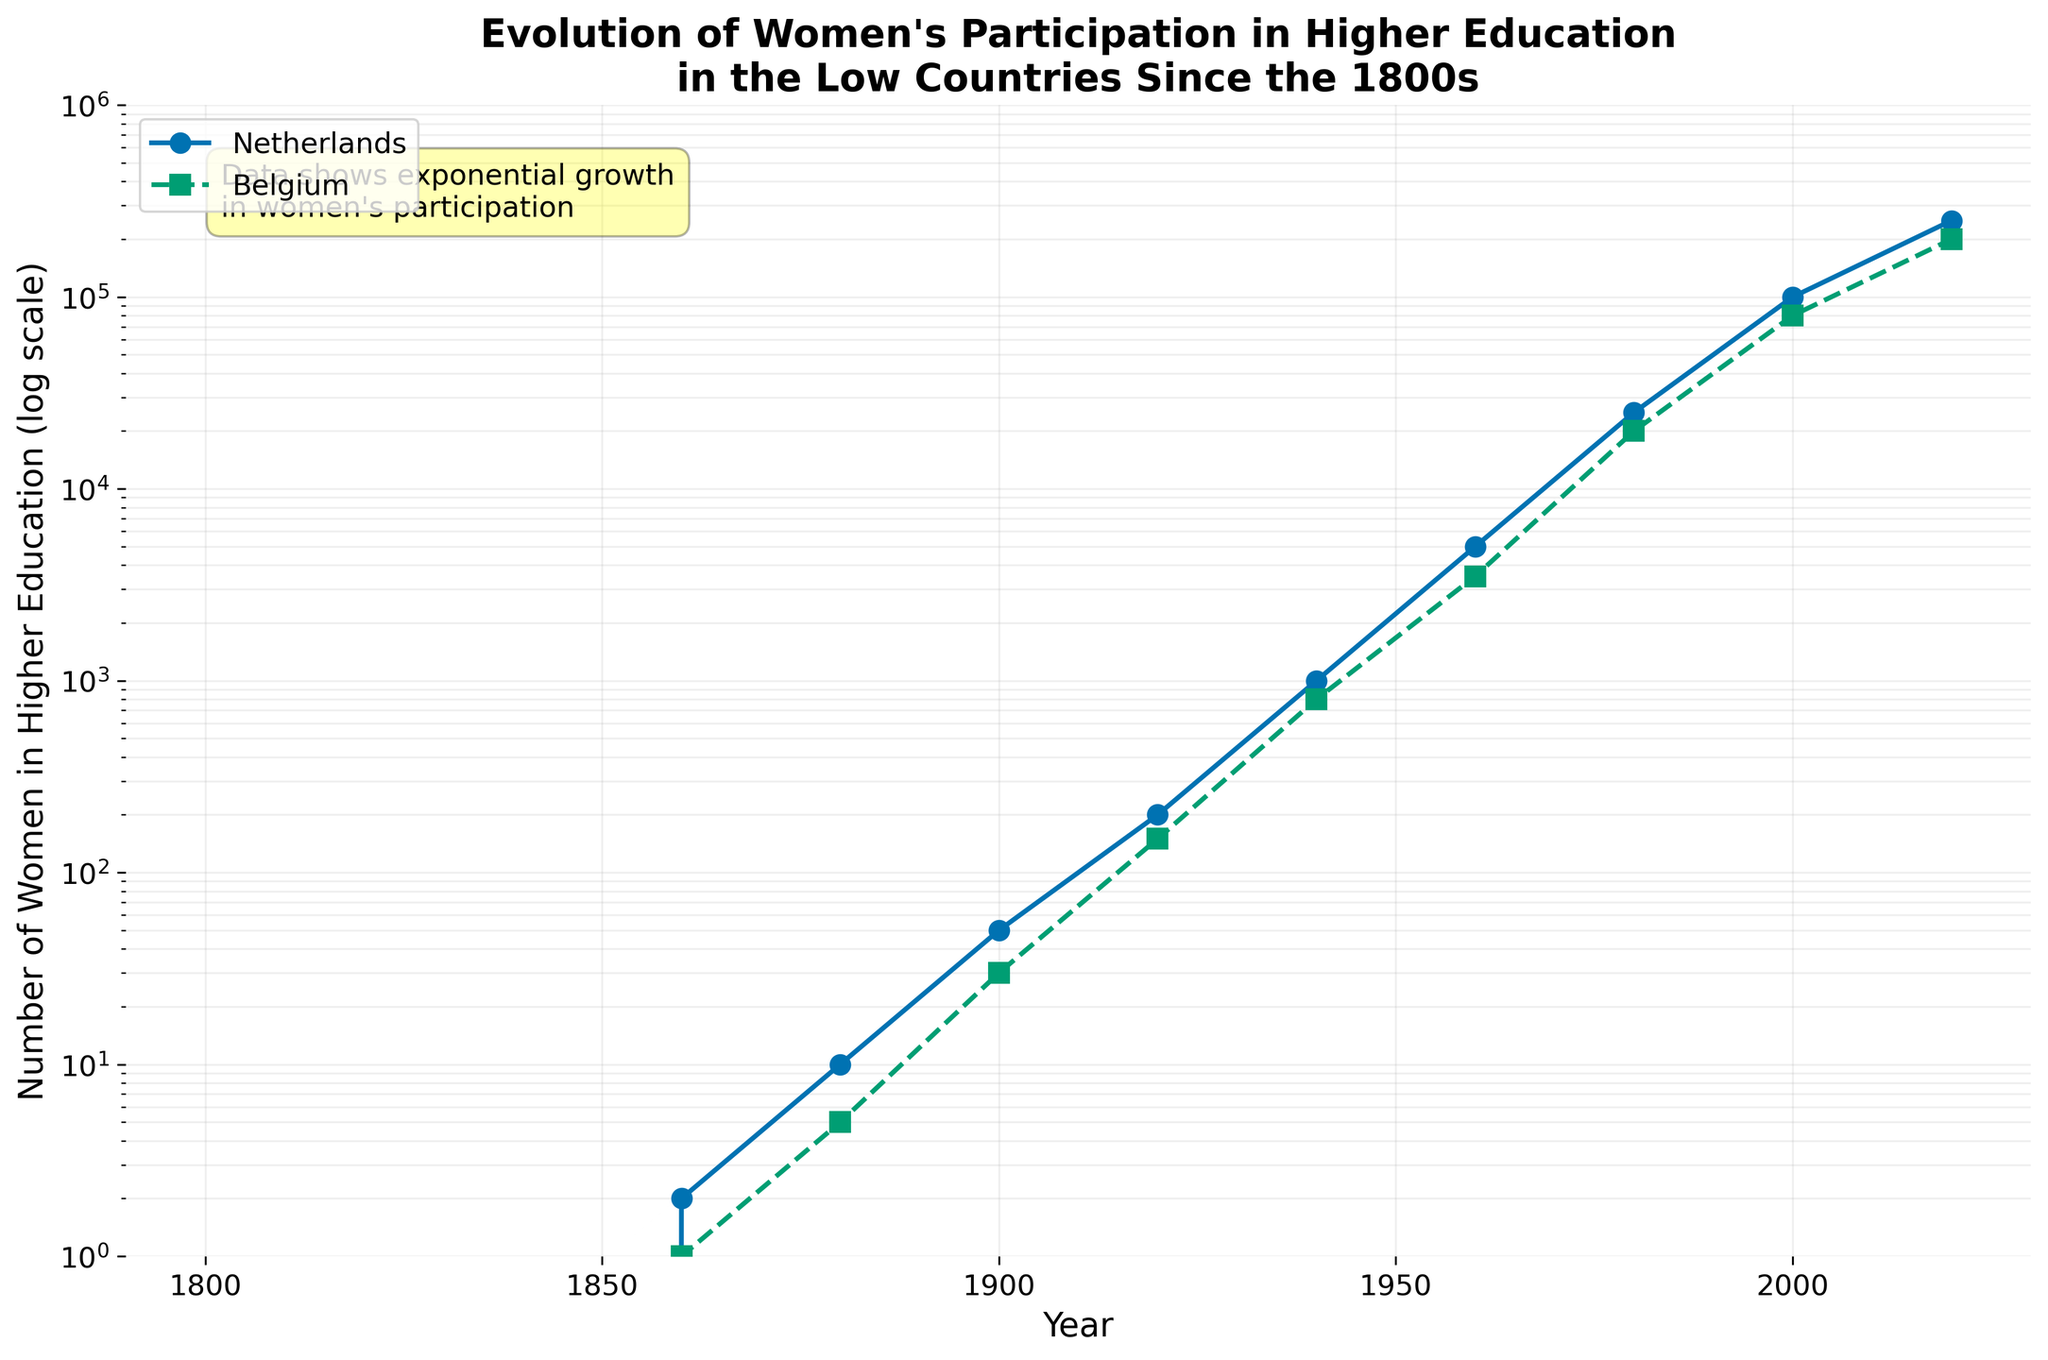What is the title of the plot? The title is written at the top of the figure. It says "Evolution of Women's Participation in Higher Education in the Low Countries Since the 1800s".
Answer: Evolution of Women's Participation in Higher Education in the Low Countries Since the 1800s Which country showed a higher number of women in higher education in 2000? Look at the corresponding data points for the year 2000 on the plot. The Netherlands has a data point at 100,000, whereas Belgium's data point is at 80,000.
Answer: Netherlands How many decades see a rise in women's participation in higher education in both countries from 1800-2020? Count the number of consecutive periods where the data points keep increasing for both countries. From 1800-2020, the rises are (1820, 1840, 1860, 1880, 1900, 1920, 1940, 1960, 1980, 2000, 2020): 11 decades.
Answer: 11 decades What was the approximate number of women in higher education in Belgium in the 1940s? Locate the 1940 data point for Belgium on the plot, which is about 800. This can be seen directly from the y-axis value.
Answer: 800 Between which periods did the Netherlands see the most significant increase in the number of women in higher education? Examine the trend lines to identify the steepest slope. The period from 1940 (1000) to 1960 (5000) shows a significant increase as the slope is very steep.
Answer: 1940-1960 Compare the trends of women's participation in higher education between the Netherlands and Belgium from 1880 to 1920. Look at the slopes of both lines between 1880 (Netherlands: 10, Belgium: 5) and 1920 (Netherlands: 200, Belgium: 150). Both countries show rapid growth, but the Netherlands has a steeper and higher increase.
Answer: Netherlands grew faster By what factor did the number of women in higher education in the Netherlands increase from 1880 to 1960? From the 1880 value (10) to the 1960 value (5000), find the ratio: 5000/10 = 500. The number increased by a factor of 500.
Answer: 500 How does the growth pattern in women's participation in higher education before 1900 compare to after 1900? Analyze the data points before and after 1900. Before 1900, growth was minimal, while after 1900, the trend shows a significant exponential increase, visible through the large differences in the log scale values.
Answer: Minimal growth before, exponential growth after What is the overall trend shown by the plot for both countries? The plot demonstrates an overall exponential increase in women's participation in higher education from 1800 to 2020, as indicated by the upward trend in both lines on the log scale.
Answer: Exponential increase How does the text annotation in the plot relate to the data trends? The text annotation says, "Data shows exponential growth in women's participation." This matches the observed trend in the plot where women's participation increases exponentially over time for both countries.
Answer: Matches observed exponential growth 